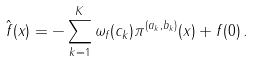Convert formula to latex. <formula><loc_0><loc_0><loc_500><loc_500>\hat { f } ( x ) = - \sum _ { k = 1 } ^ { K } \omega _ { f } ( c _ { k } ) \pi ^ { ( a _ { k } , b _ { k } ) } ( x ) + f ( 0 ) \, .</formula> 